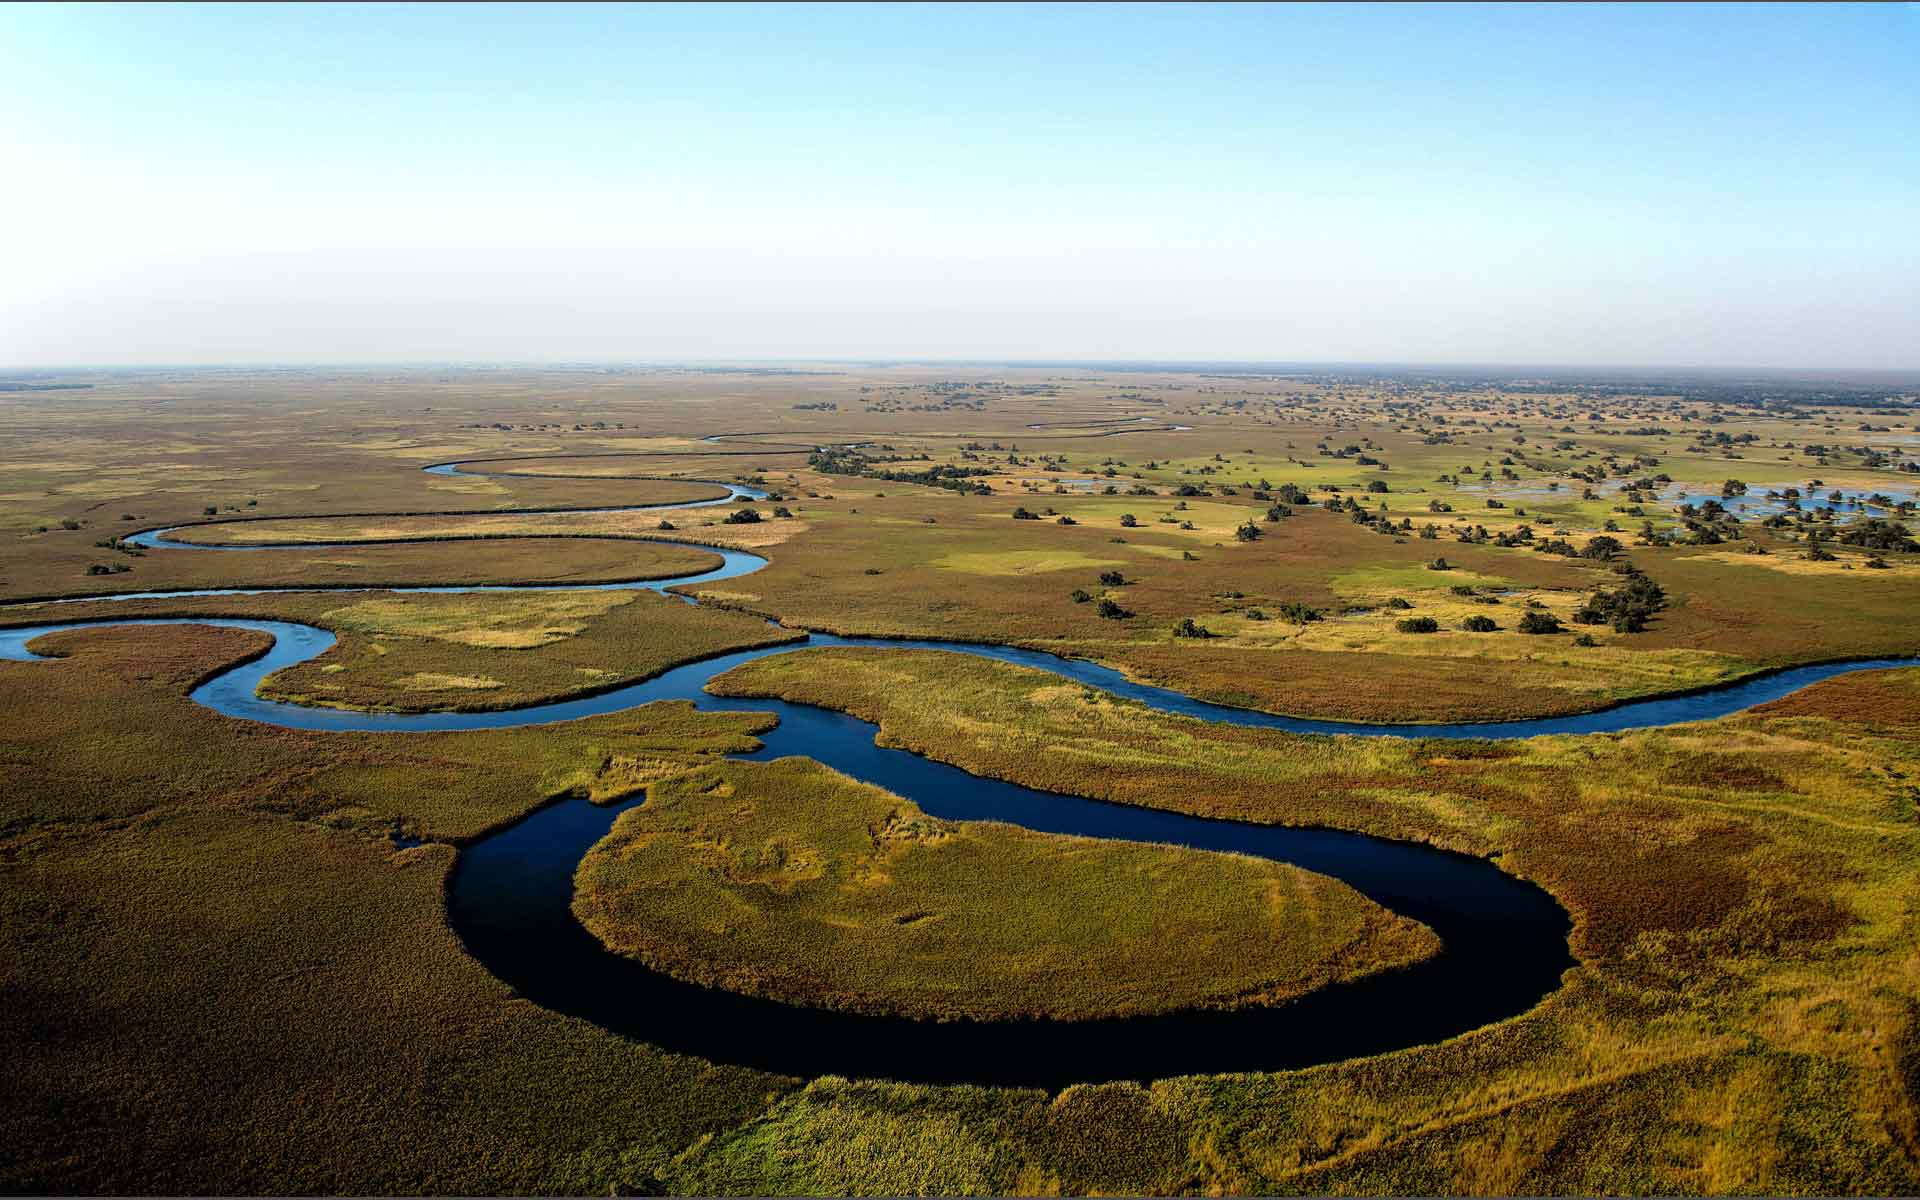Write a detailed description of the given image. The image provides a stunning aerial view of the Okavango Delta, located in northern Botswana. This vast inland river delta is known for its lush greenery and intricate blue waterways that meander through a sprawling savanna landscape. The delta creates mesmerizing patterns that weave through various shades of green and brown vegetation, reflecting its dynamic water flow that supports a diverse ecosystem. Visible in the image are numerous water bodies interconnected by narrow channels, against a backdrop of a vast, flat horizon where the land meets a clear sky. This area is a critical habitat for wildlife, including elephants, hippos, and myriad bird species, playing a crucial ecological role in the region. 